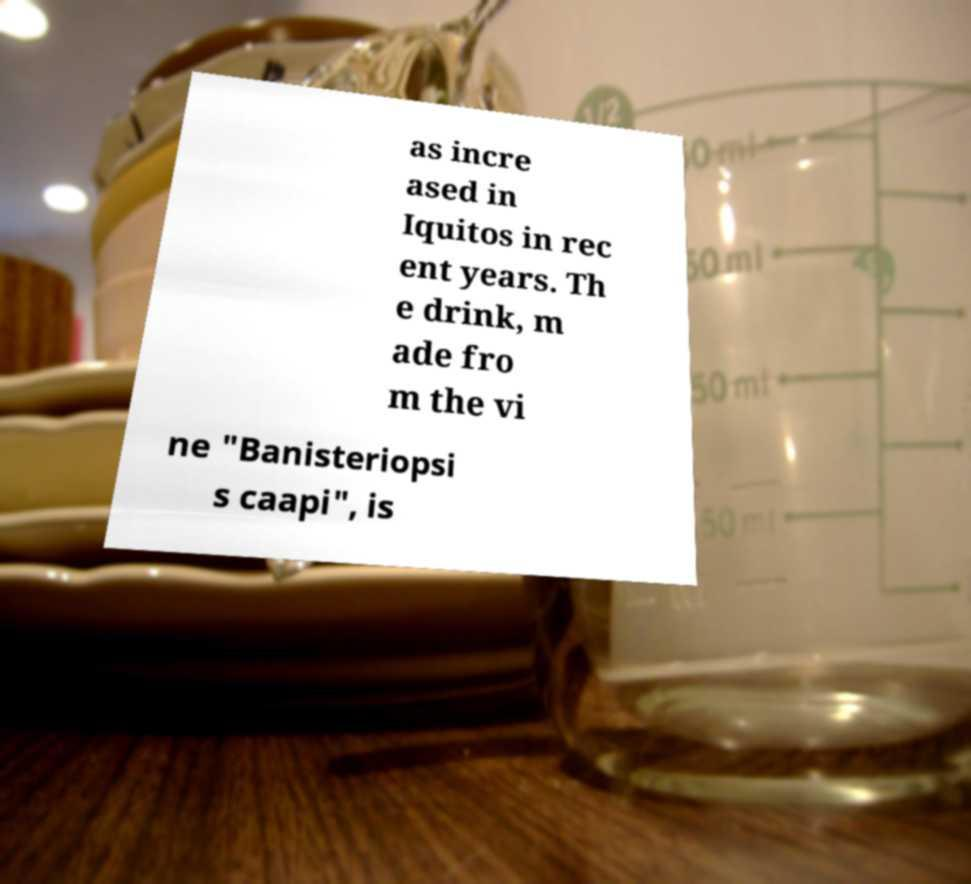What messages or text are displayed in this image? I need them in a readable, typed format. as incre ased in Iquitos in rec ent years. Th e drink, m ade fro m the vi ne "Banisteriopsi s caapi", is 